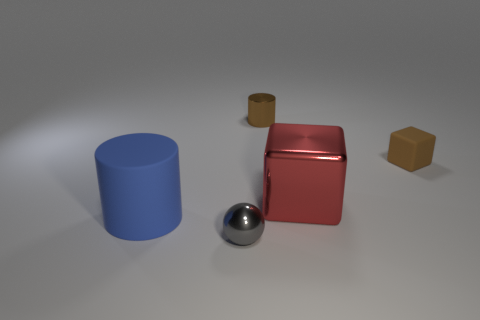What material is the tiny cube that is the same color as the small shiny cylinder?
Your answer should be compact. Rubber. How many big metal objects have the same shape as the small gray object?
Give a very brief answer. 0. Does the small ball have the same material as the small thing on the right side of the tiny brown metal cylinder?
Offer a terse response. No. What is the material of the brown cylinder that is the same size as the gray object?
Keep it short and to the point. Metal. Is there a blue matte cylinder of the same size as the metal sphere?
Your answer should be very brief. No. The matte object that is the same size as the gray sphere is what shape?
Provide a short and direct response. Cube. How many other objects are the same color as the tiny metallic cylinder?
Provide a short and direct response. 1. There is a thing that is in front of the large metal block and right of the large blue matte cylinder; what is its shape?
Offer a terse response. Sphere. There is a metallic object in front of the big thing to the right of the gray shiny sphere; is there a big red cube behind it?
Your answer should be very brief. Yes. What number of other things are there of the same material as the gray ball
Ensure brevity in your answer.  2. 